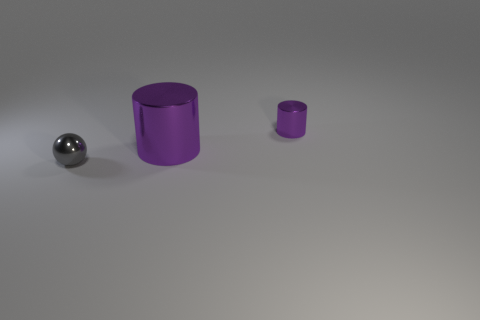Is the surface on which the objects are placed horizontal or tilted? The surface appears to be horizontal as there are no visible indicators such as shadows or object orientations that would suggest a tilt. 